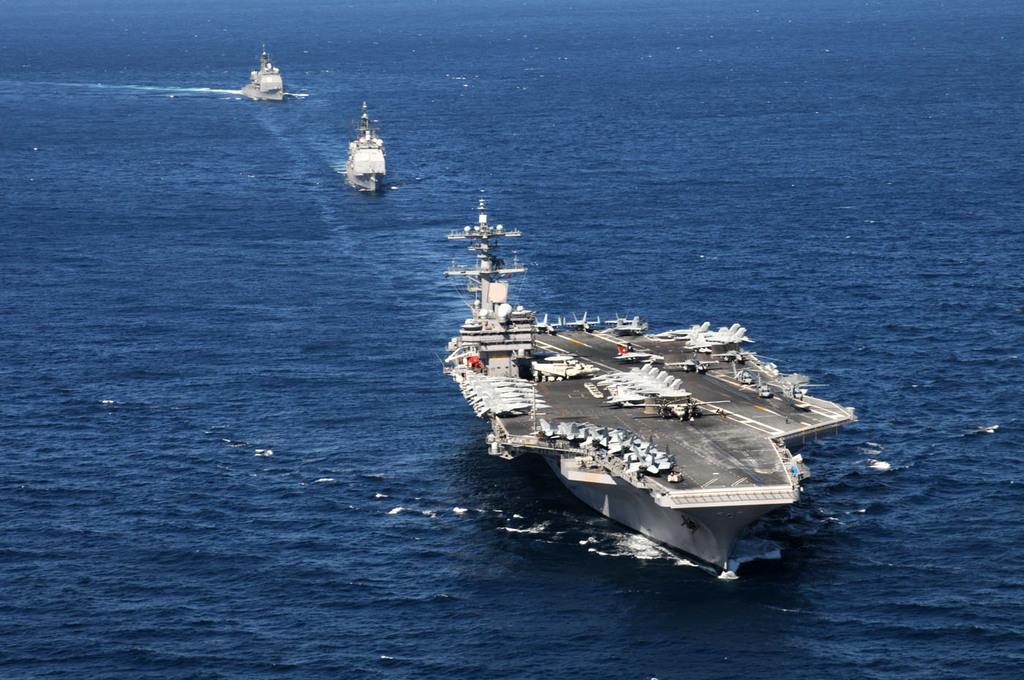Could you give a brief overview of what you see in this image? In this image we can see three boats on the surface of the sea. 